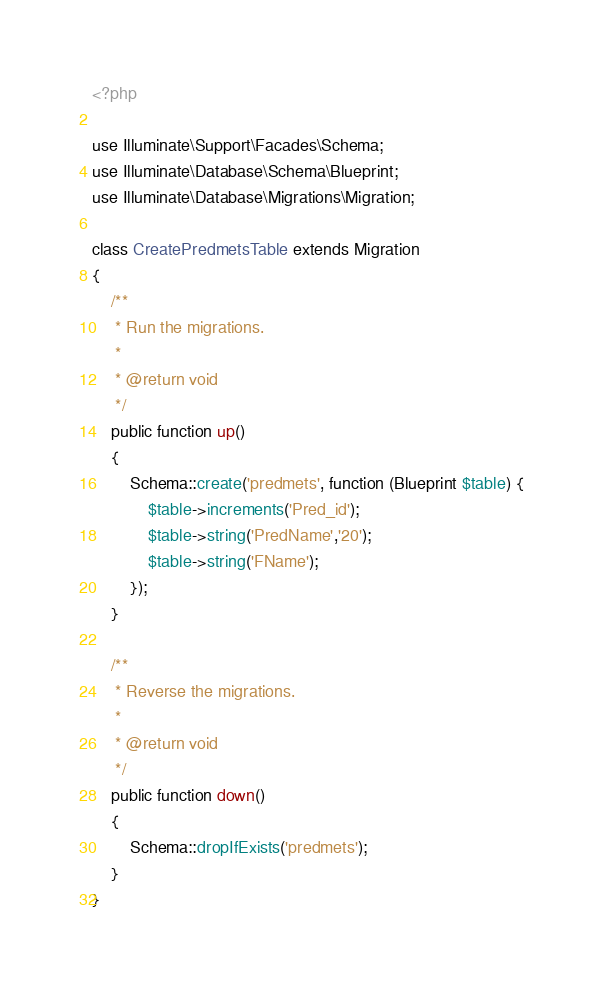<code> <loc_0><loc_0><loc_500><loc_500><_PHP_><?php

use Illuminate\Support\Facades\Schema;
use Illuminate\Database\Schema\Blueprint;
use Illuminate\Database\Migrations\Migration;

class CreatePredmetsTable extends Migration
{
    /**
     * Run the migrations.
     *
     * @return void
     */
    public function up()
    {
        Schema::create('predmets', function (Blueprint $table) {
            $table->increments('Pred_id');
            $table->string('PredName','20');
            $table->string('FName');
        });
    }

    /**
     * Reverse the migrations.
     *
     * @return void
     */
    public function down()
    {
        Schema::dropIfExists('predmets');
    }
}
</code> 